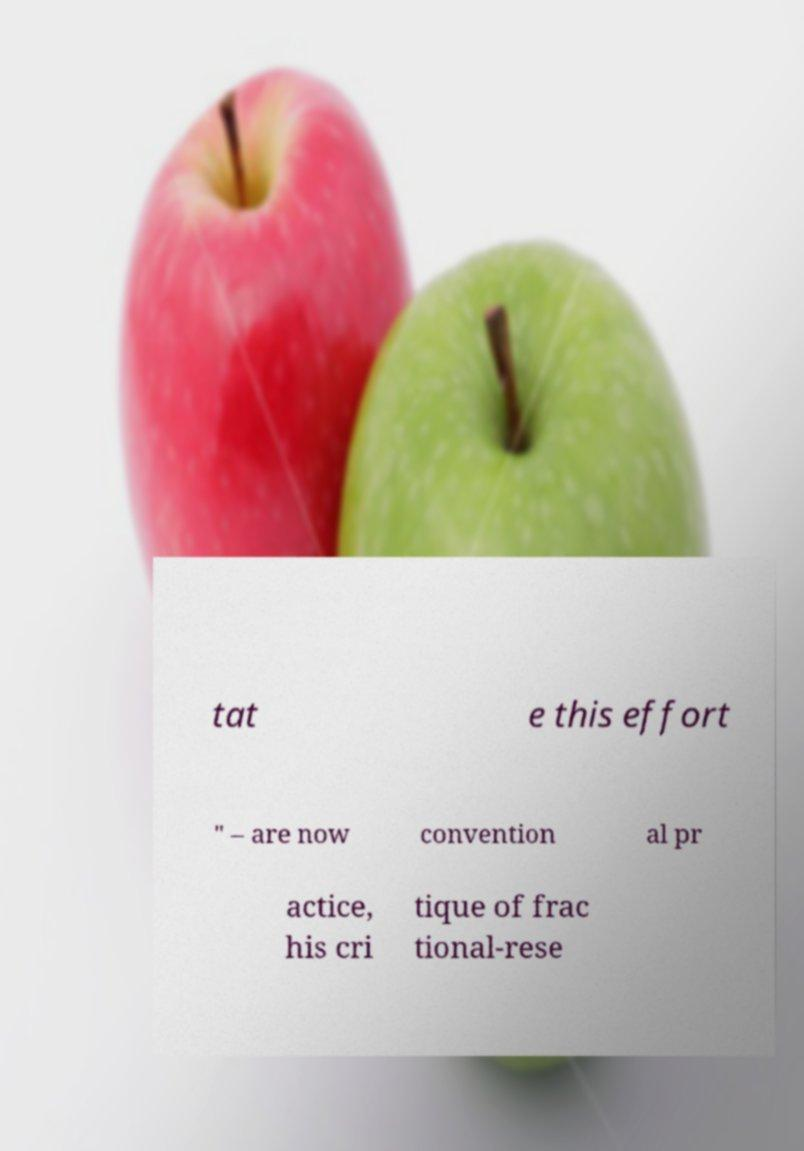For documentation purposes, I need the text within this image transcribed. Could you provide that? tat e this effort " – are now convention al pr actice, his cri tique of frac tional-rese 